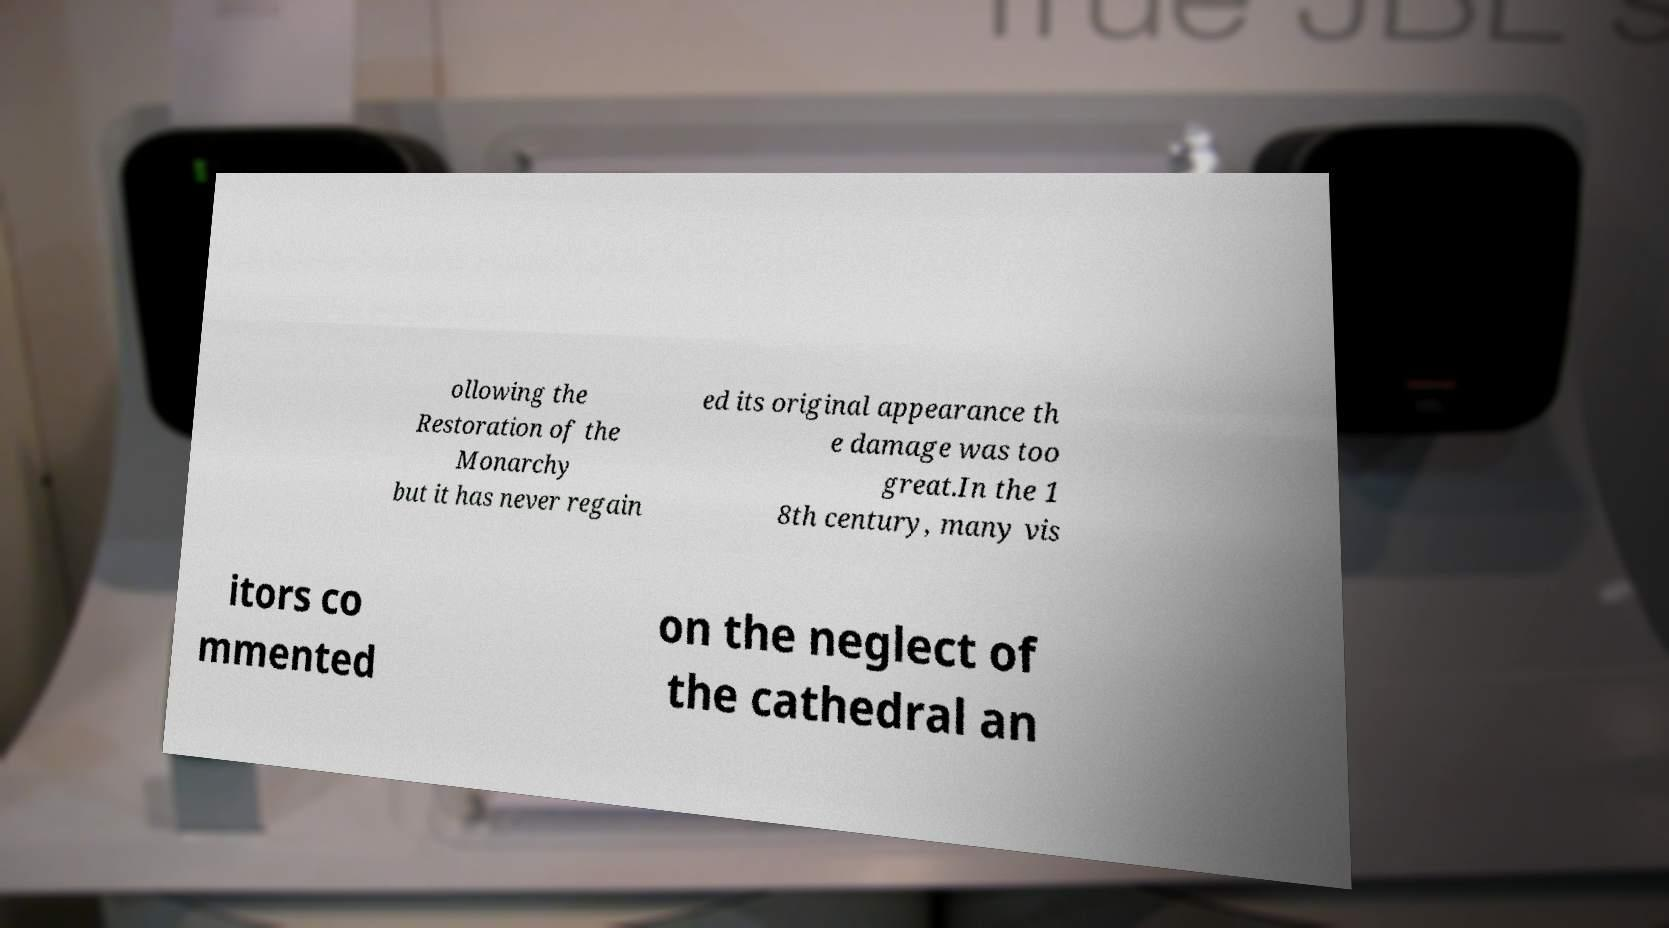Can you accurately transcribe the text from the provided image for me? ollowing the Restoration of the Monarchy but it has never regain ed its original appearance th e damage was too great.In the 1 8th century, many vis itors co mmented on the neglect of the cathedral an 